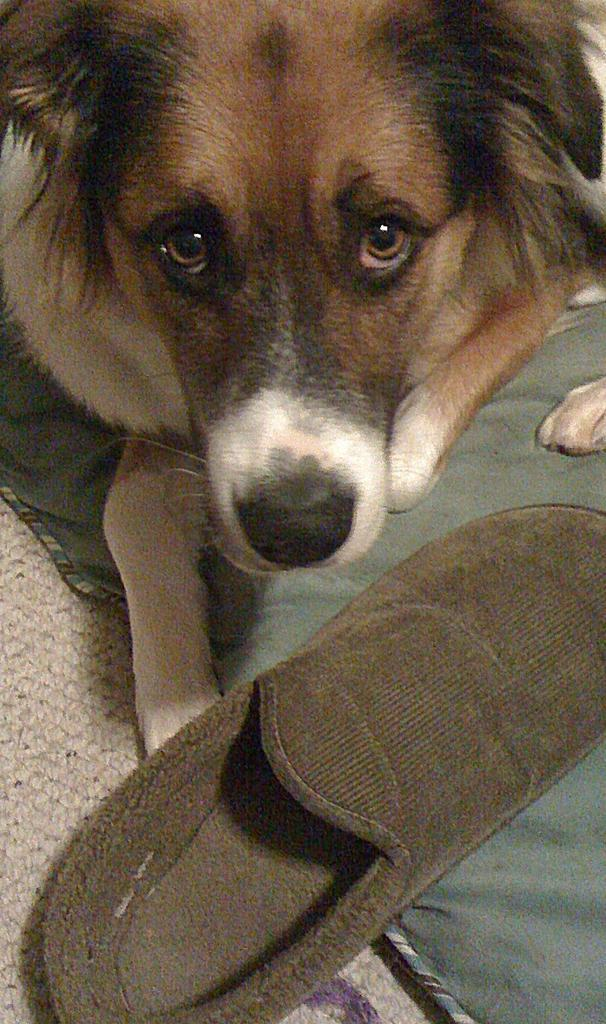What type of animal is present in the image? There is a dog in the image. What other object can be seen in the image? There is a shoe in the image. What is on the floor in the image? There is a mat on the floor in the image. What type of rake is being used in the protest depicted in the image? There is no protest or rake present in the image; it features a dog, a shoe, and a mat on the floor. 